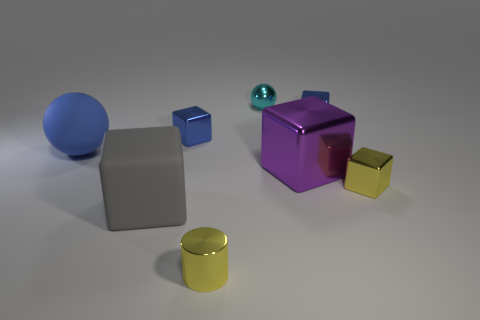What is the shape of the tiny metal object that is in front of the tiny yellow shiny object that is behind the matte cube?
Keep it short and to the point. Cylinder. There is a tiny yellow metallic object behind the small metal thing in front of the big cube to the left of the purple object; what shape is it?
Your answer should be compact. Cube. How many small yellow things have the same shape as the blue matte object?
Provide a succinct answer. 0. How many tiny shiny balls are in front of the large rubber object that is right of the blue sphere?
Provide a succinct answer. 0. What number of metallic things are tiny cyan spheres or tiny blue blocks?
Ensure brevity in your answer.  3. Are there any large purple cylinders that have the same material as the yellow block?
Your answer should be very brief. No. How many things are small things that are behind the matte cube or objects on the right side of the small cyan shiny object?
Make the answer very short. 5. There is a tiny cube that is in front of the large blue rubber ball; is its color the same as the small metallic cylinder?
Give a very brief answer. Yes. What number of other things are there of the same color as the large rubber ball?
Provide a succinct answer. 2. What is the material of the tiny cyan sphere?
Offer a very short reply. Metal. 